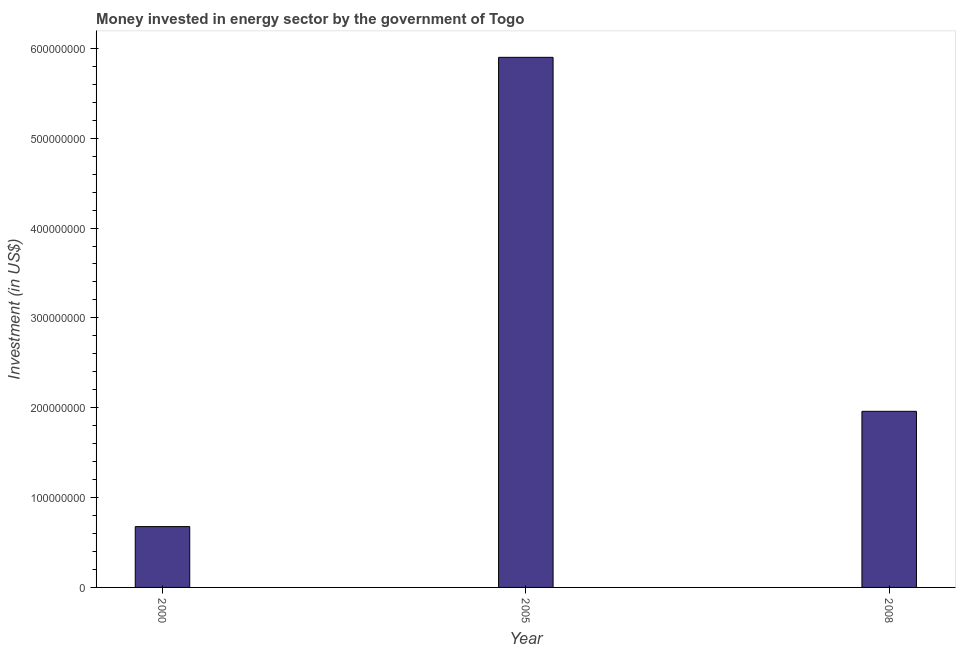Does the graph contain grids?
Your answer should be compact. No. What is the title of the graph?
Your answer should be compact. Money invested in energy sector by the government of Togo. What is the label or title of the Y-axis?
Provide a succinct answer. Investment (in US$). What is the investment in energy in 2008?
Give a very brief answer. 1.96e+08. Across all years, what is the maximum investment in energy?
Give a very brief answer. 5.90e+08. Across all years, what is the minimum investment in energy?
Make the answer very short. 6.77e+07. What is the sum of the investment in energy?
Provide a short and direct response. 8.54e+08. What is the difference between the investment in energy in 2000 and 2008?
Keep it short and to the point. -1.28e+08. What is the average investment in energy per year?
Your answer should be compact. 2.85e+08. What is the median investment in energy?
Give a very brief answer. 1.96e+08. In how many years, is the investment in energy greater than 520000000 US$?
Make the answer very short. 1. What is the ratio of the investment in energy in 2000 to that in 2008?
Your response must be concise. 0.34. Is the investment in energy in 2000 less than that in 2005?
Offer a terse response. Yes. Is the difference between the investment in energy in 2005 and 2008 greater than the difference between any two years?
Ensure brevity in your answer.  No. What is the difference between the highest and the second highest investment in energy?
Offer a very short reply. 3.94e+08. Is the sum of the investment in energy in 2000 and 2005 greater than the maximum investment in energy across all years?
Keep it short and to the point. Yes. What is the difference between the highest and the lowest investment in energy?
Offer a very short reply. 5.22e+08. In how many years, is the investment in energy greater than the average investment in energy taken over all years?
Make the answer very short. 1. How many bars are there?
Your response must be concise. 3. How many years are there in the graph?
Ensure brevity in your answer.  3. What is the Investment (in US$) of 2000?
Make the answer very short. 6.77e+07. What is the Investment (in US$) of 2005?
Keep it short and to the point. 5.90e+08. What is the Investment (in US$) of 2008?
Give a very brief answer. 1.96e+08. What is the difference between the Investment (in US$) in 2000 and 2005?
Give a very brief answer. -5.22e+08. What is the difference between the Investment (in US$) in 2000 and 2008?
Your response must be concise. -1.28e+08. What is the difference between the Investment (in US$) in 2005 and 2008?
Give a very brief answer. 3.94e+08. What is the ratio of the Investment (in US$) in 2000 to that in 2005?
Offer a terse response. 0.12. What is the ratio of the Investment (in US$) in 2000 to that in 2008?
Keep it short and to the point. 0.34. What is the ratio of the Investment (in US$) in 2005 to that in 2008?
Make the answer very short. 3.01. 